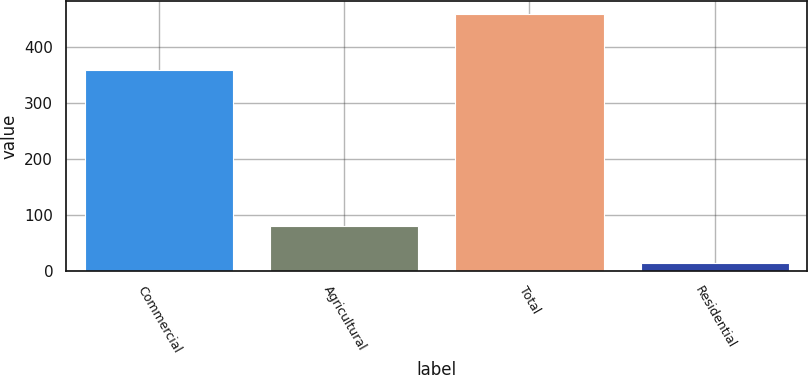Convert chart to OTSL. <chart><loc_0><loc_0><loc_500><loc_500><bar_chart><fcel>Commercial<fcel>Agricultural<fcel>Total<fcel>Residential<nl><fcel>359<fcel>80<fcel>458<fcel>14<nl></chart> 